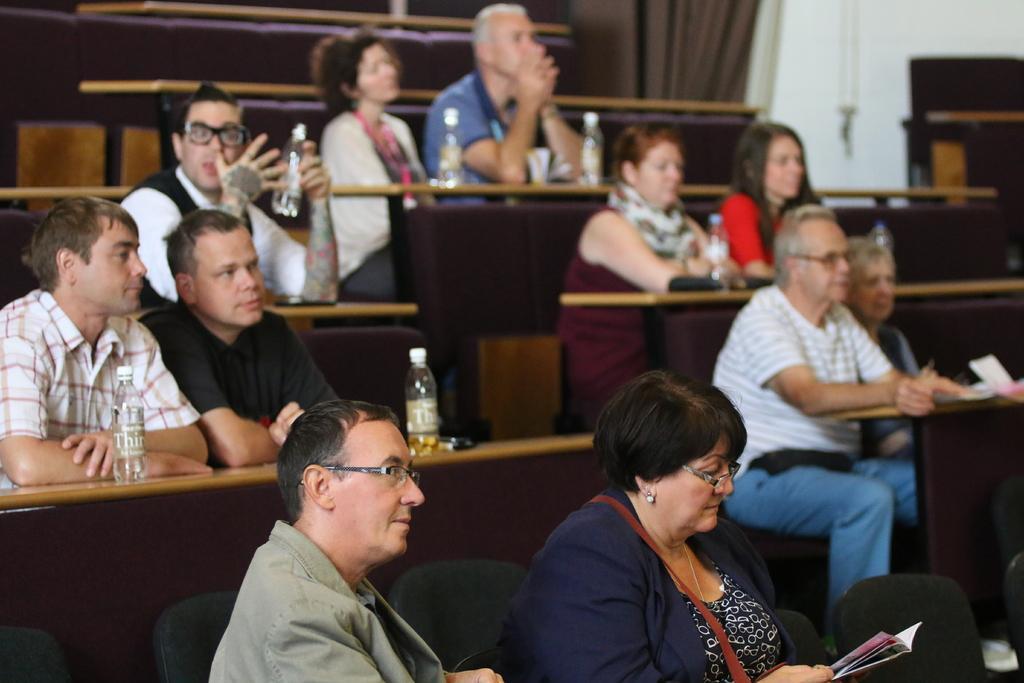Could you give a brief overview of what you see in this image? In this image we can see these people are sitting on the chair near the wooden tables. Here we can see bottles on the table. The background of the image is slightly blurred, where we can see the curtains and the wall. 